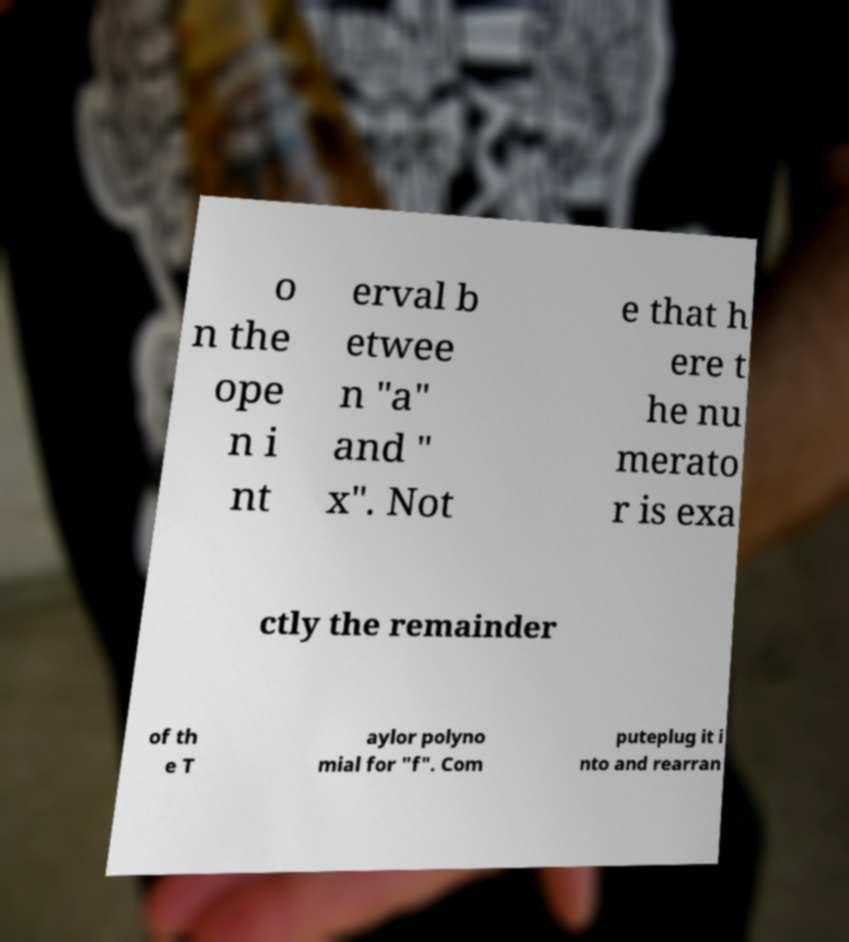There's text embedded in this image that I need extracted. Can you transcribe it verbatim? o n the ope n i nt erval b etwee n "a" and " x". Not e that h ere t he nu merato r is exa ctly the remainder of th e T aylor polyno mial for "f". Com puteplug it i nto and rearran 